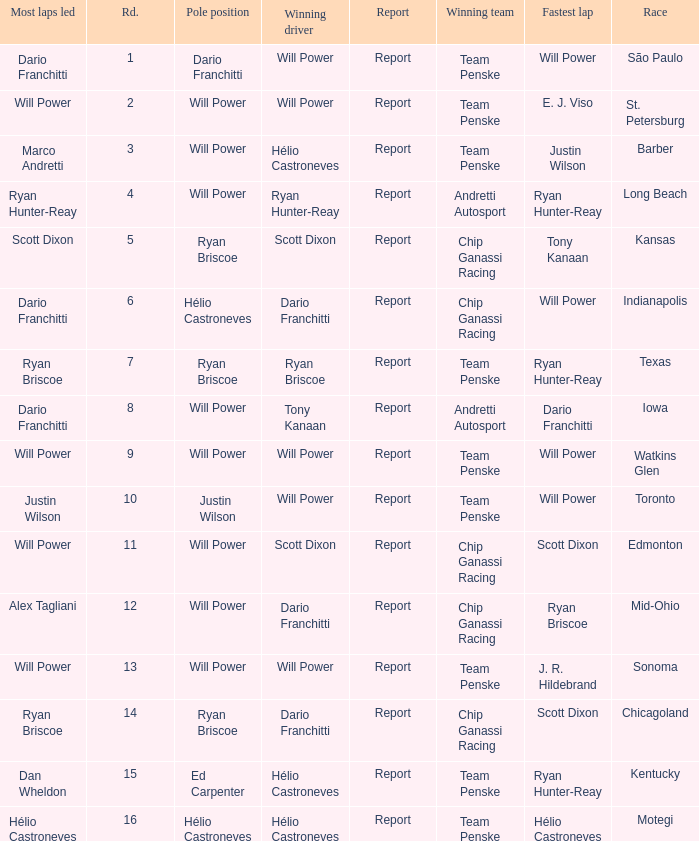In what position did the winning driver finish at Chicagoland? 1.0. 